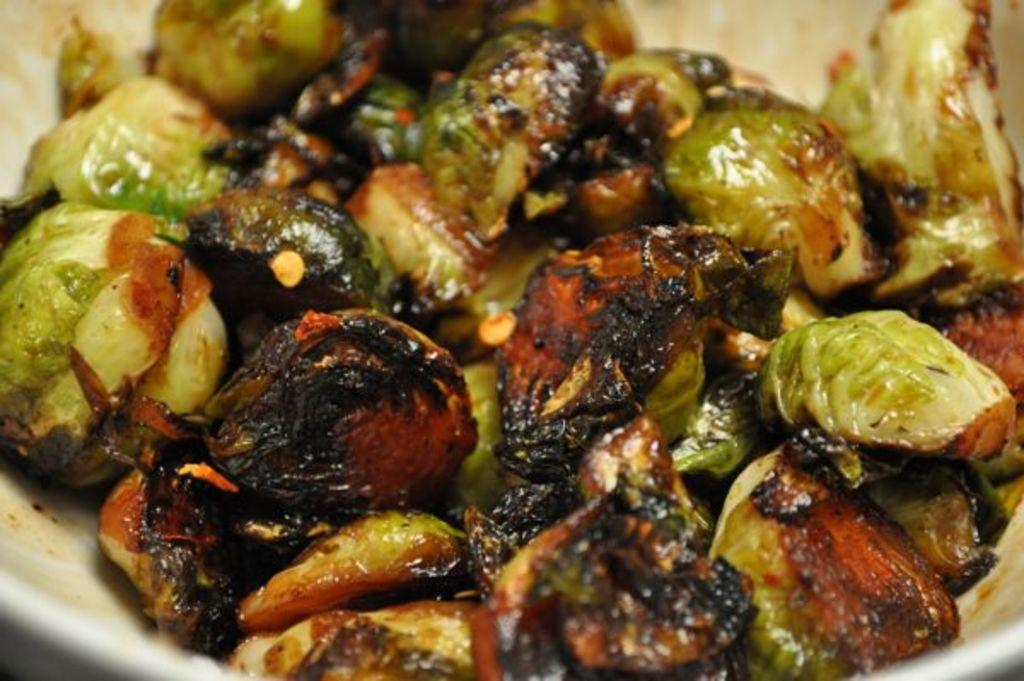What is in the bowl that is visible in the image? There are food items in a bowl in the image. What type of toothbrush is used to clean the food items in the image? There is no toothbrush present in the image, and the food items are not being cleaned. Can you see any magic happening with the food items in the image? There is no magic present in the image; it simply shows food items in a bowl. 